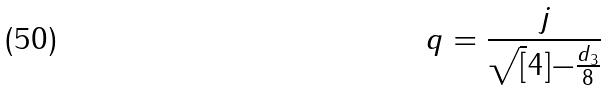<formula> <loc_0><loc_0><loc_500><loc_500>q = \frac { j } { \sqrt { [ } 4 ] { - \frac { d _ { 3 } } { 8 } } }</formula> 